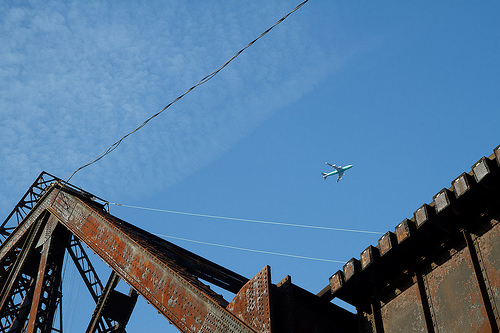Please provide a short description for this region: [0.1, 0.55, 0.55, 0.83]. A robust steel beam forming part of a larger structure. 